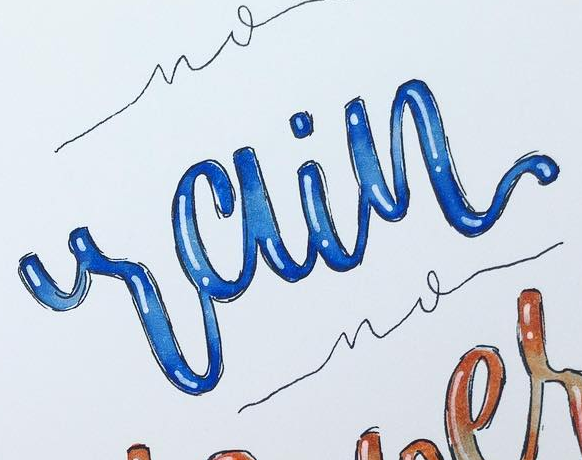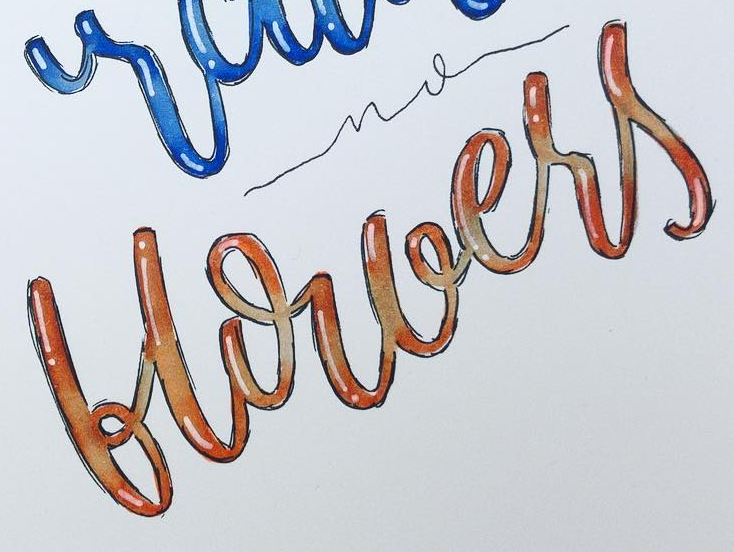What text appears in these images from left to right, separated by a semicolon? rain; blouers 